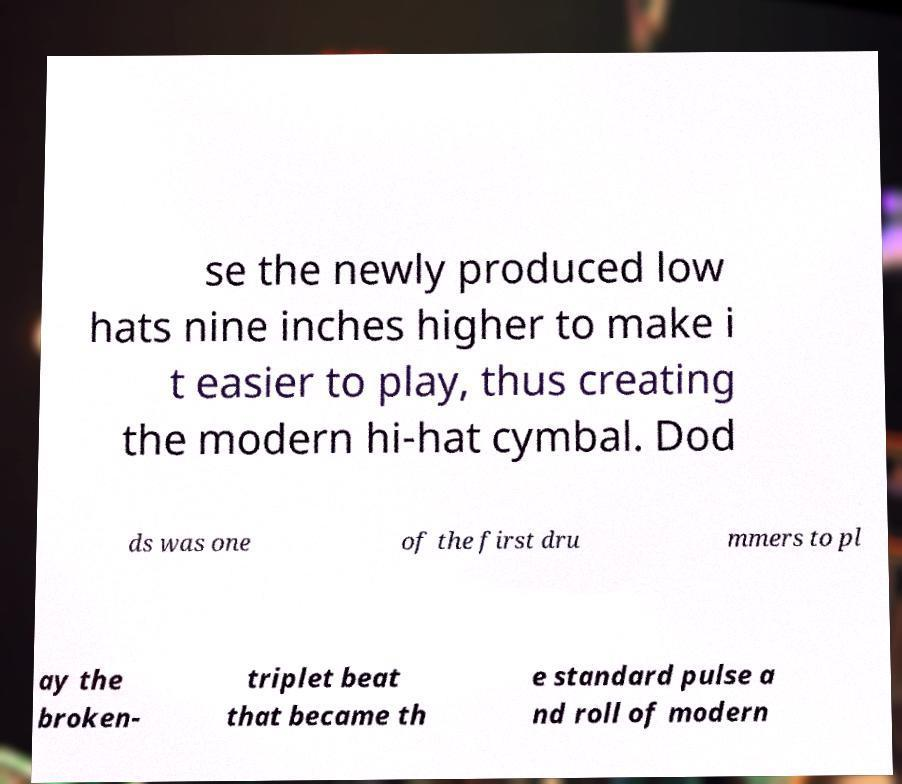Can you read and provide the text displayed in the image?This photo seems to have some interesting text. Can you extract and type it out for me? se the newly produced low hats nine inches higher to make i t easier to play, thus creating the modern hi-hat cymbal. Dod ds was one of the first dru mmers to pl ay the broken- triplet beat that became th e standard pulse a nd roll of modern 